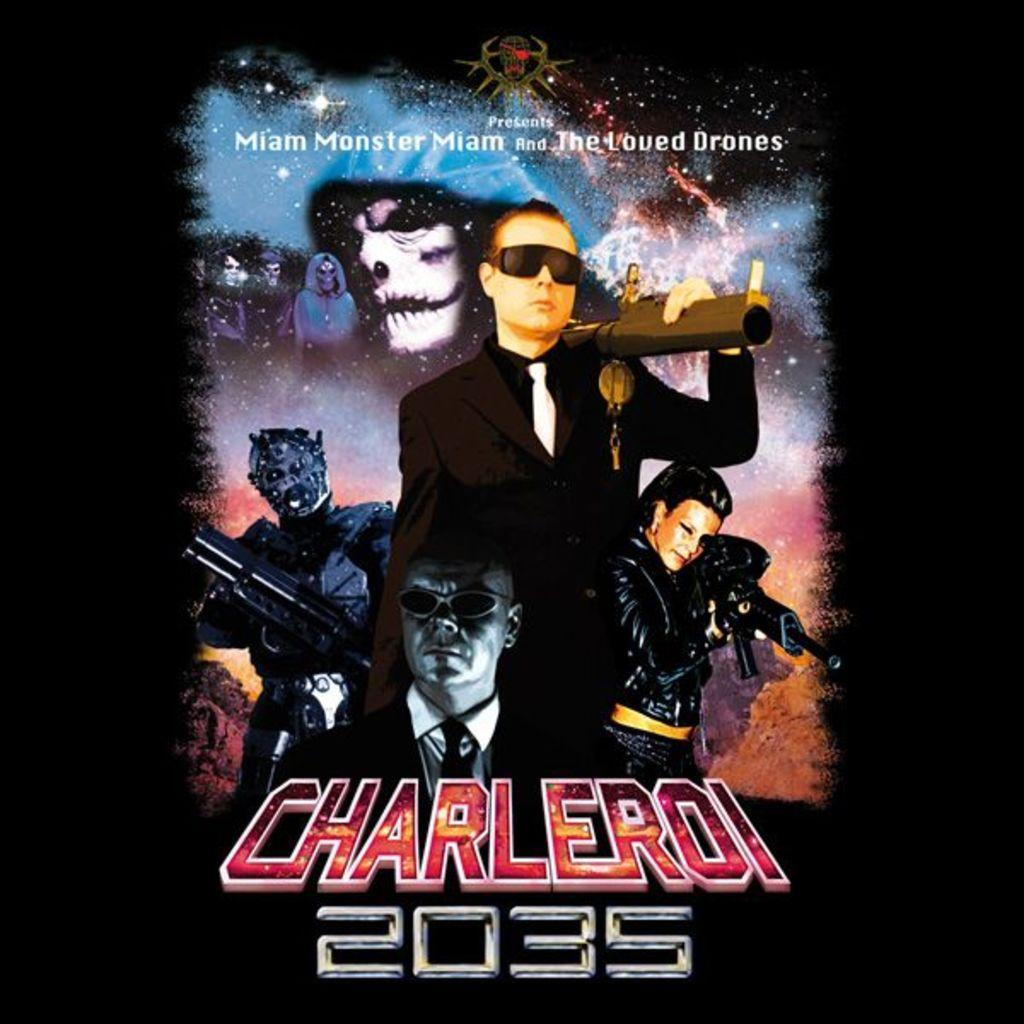<image>
Write a terse but informative summary of the picture. A move poster for Charleroi with the year 2035. 